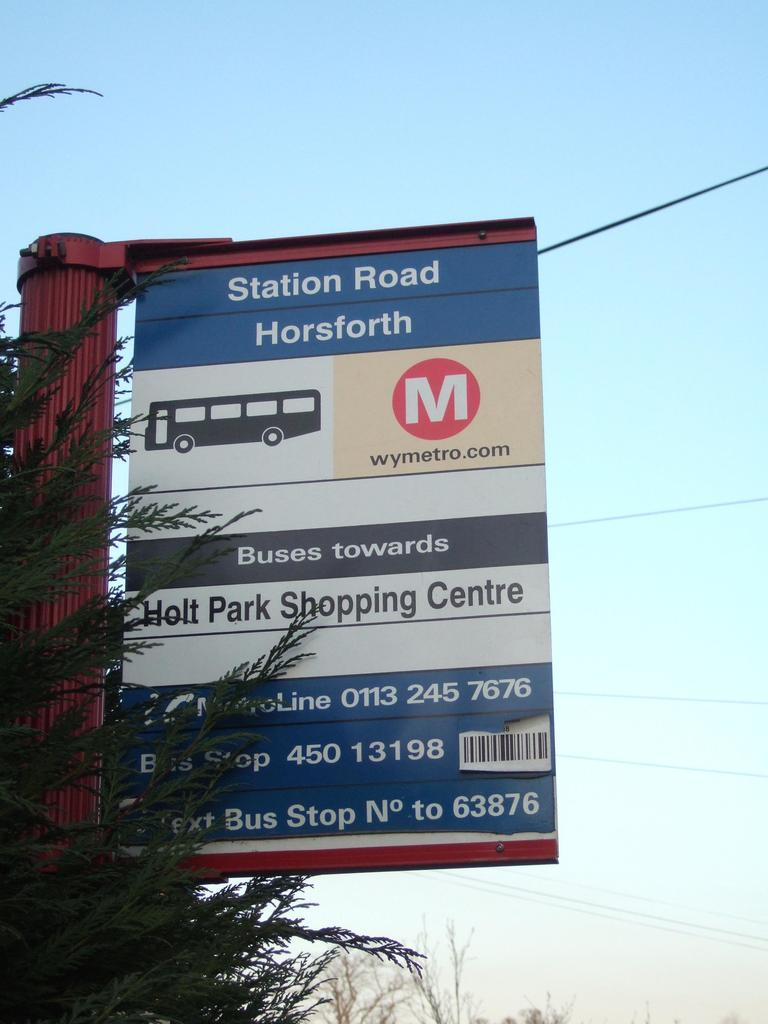<image>
Create a compact narrative representing the image presented. A sign indicates Station Road Horsforth along with other information. 